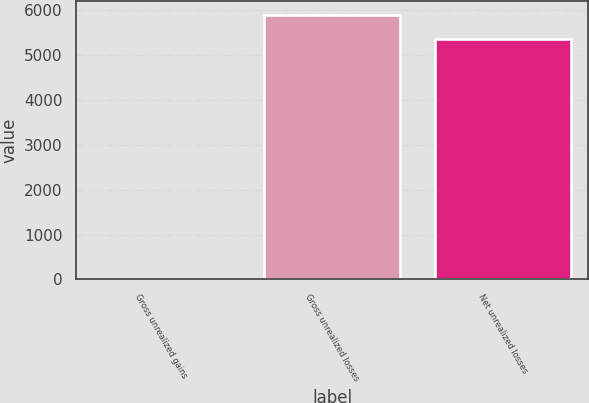Convert chart. <chart><loc_0><loc_0><loc_500><loc_500><bar_chart><fcel>Gross unrealized gains<fcel>Gross unrealized losses<fcel>Net unrealized losses<nl><fcel>13<fcel>5898.2<fcel>5362<nl></chart> 